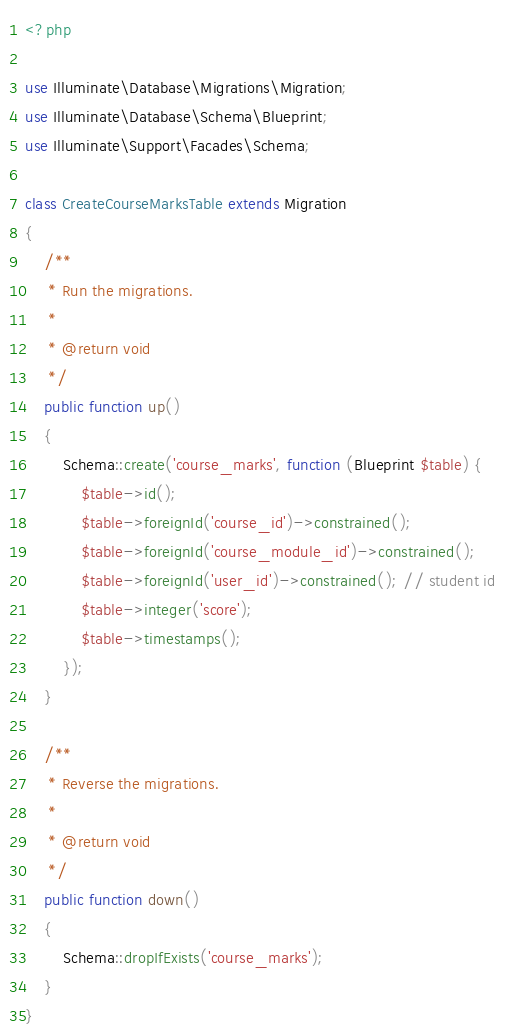Convert code to text. <code><loc_0><loc_0><loc_500><loc_500><_PHP_><?php

use Illuminate\Database\Migrations\Migration;
use Illuminate\Database\Schema\Blueprint;
use Illuminate\Support\Facades\Schema;

class CreateCourseMarksTable extends Migration
{
    /**
     * Run the migrations.
     *
     * @return void
     */
    public function up()
    {
        Schema::create('course_marks', function (Blueprint $table) {
            $table->id();
            $table->foreignId('course_id')->constrained();
            $table->foreignId('course_module_id')->constrained();
            $table->foreignId('user_id')->constrained(); // student id
            $table->integer('score');
            $table->timestamps();
        });
    }

    /**
     * Reverse the migrations.
     *
     * @return void
     */
    public function down()
    {
        Schema::dropIfExists('course_marks');
    }
}
</code> 